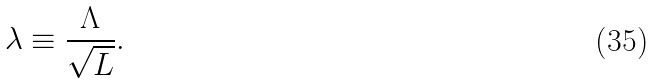<formula> <loc_0><loc_0><loc_500><loc_500>\lambda \equiv \frac { \Lambda } { \sqrt { L } } .</formula> 